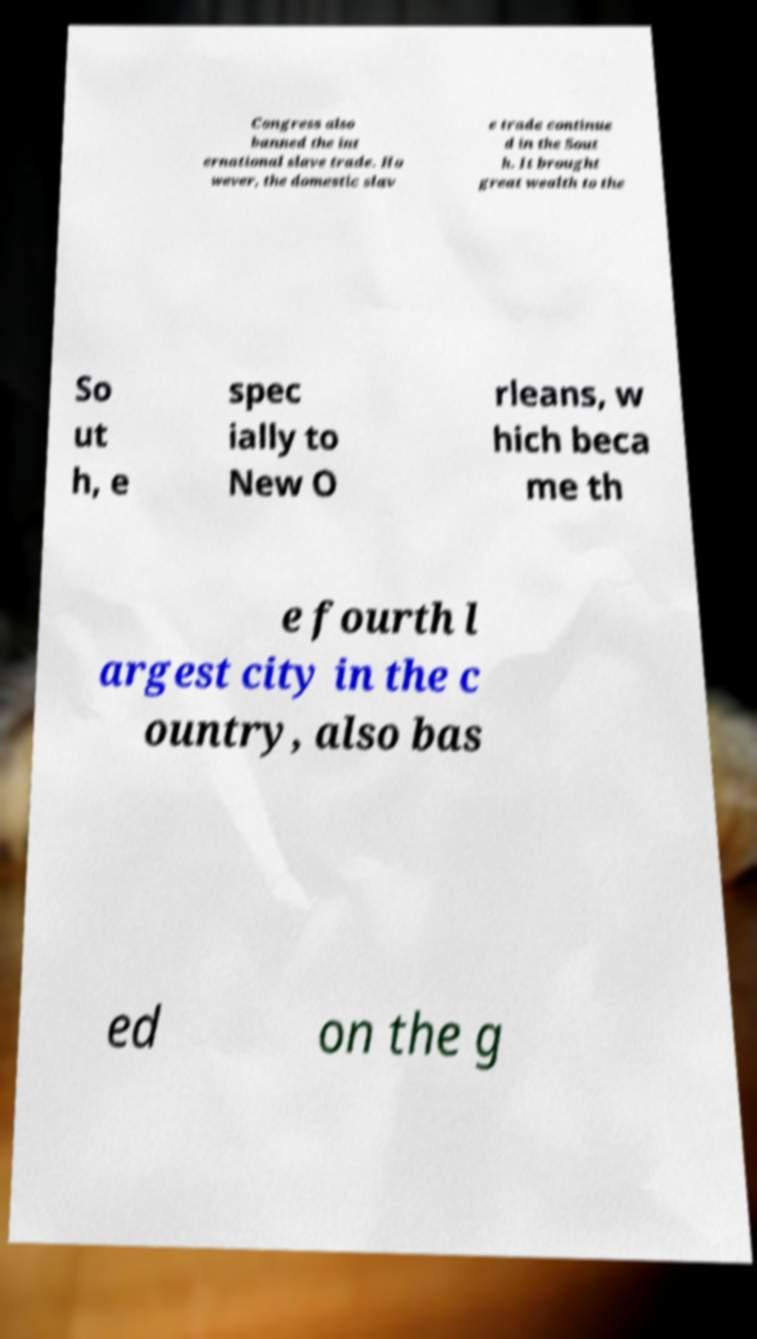Can you accurately transcribe the text from the provided image for me? Congress also banned the int ernational slave trade. Ho wever, the domestic slav e trade continue d in the Sout h. It brought great wealth to the So ut h, e spec ially to New O rleans, w hich beca me th e fourth l argest city in the c ountry, also bas ed on the g 